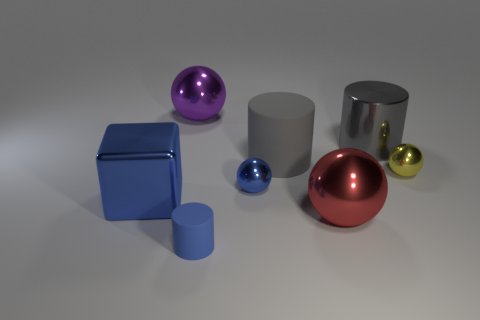Subtract 1 spheres. How many spheres are left? 3 Add 2 purple rubber spheres. How many objects exist? 10 Subtract all cubes. How many objects are left? 7 Subtract all large gray rubber objects. Subtract all metal objects. How many objects are left? 1 Add 6 big purple objects. How many big purple objects are left? 7 Add 1 blue cylinders. How many blue cylinders exist? 2 Subtract 1 blue blocks. How many objects are left? 7 